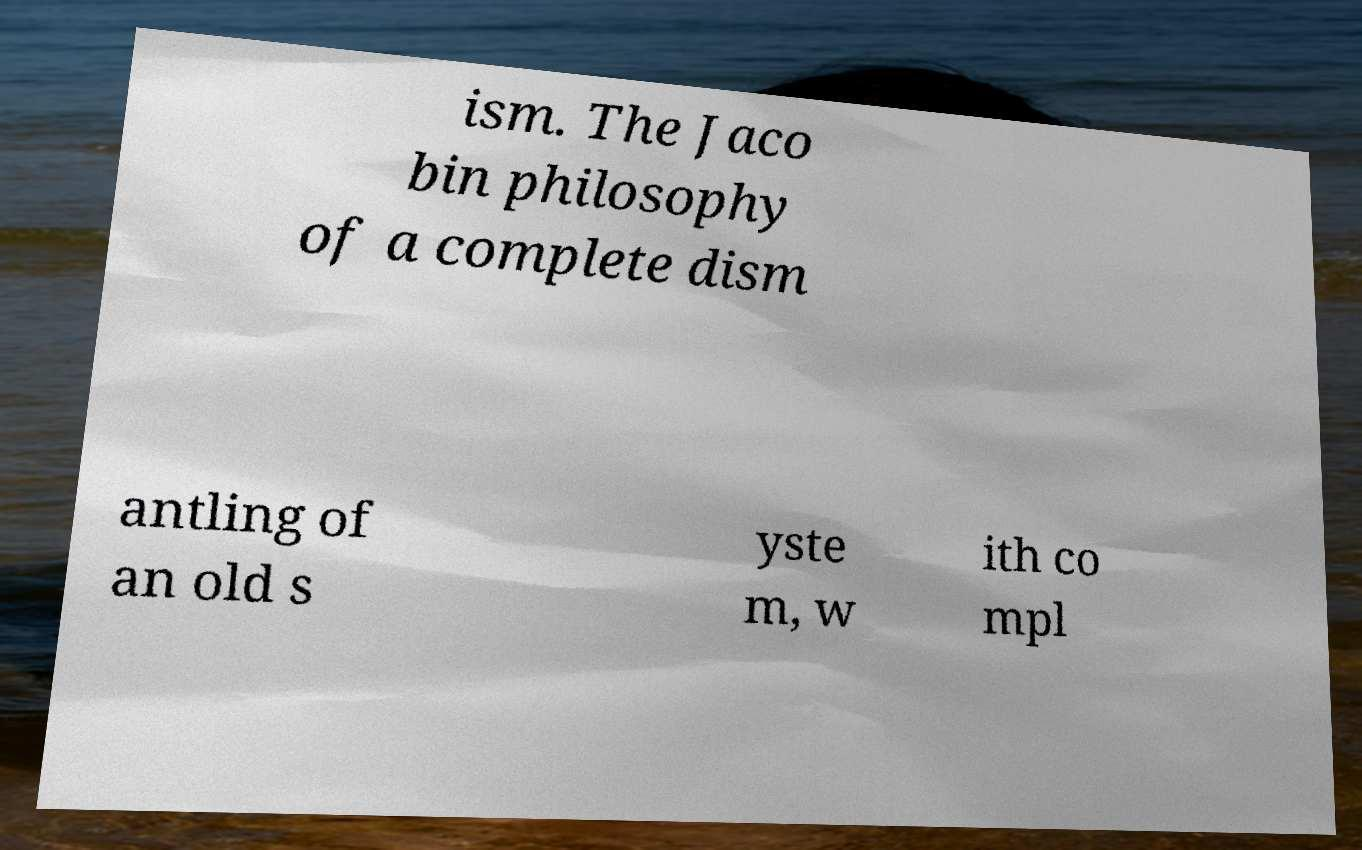Could you assist in decoding the text presented in this image and type it out clearly? ism. The Jaco bin philosophy of a complete dism antling of an old s yste m, w ith co mpl 